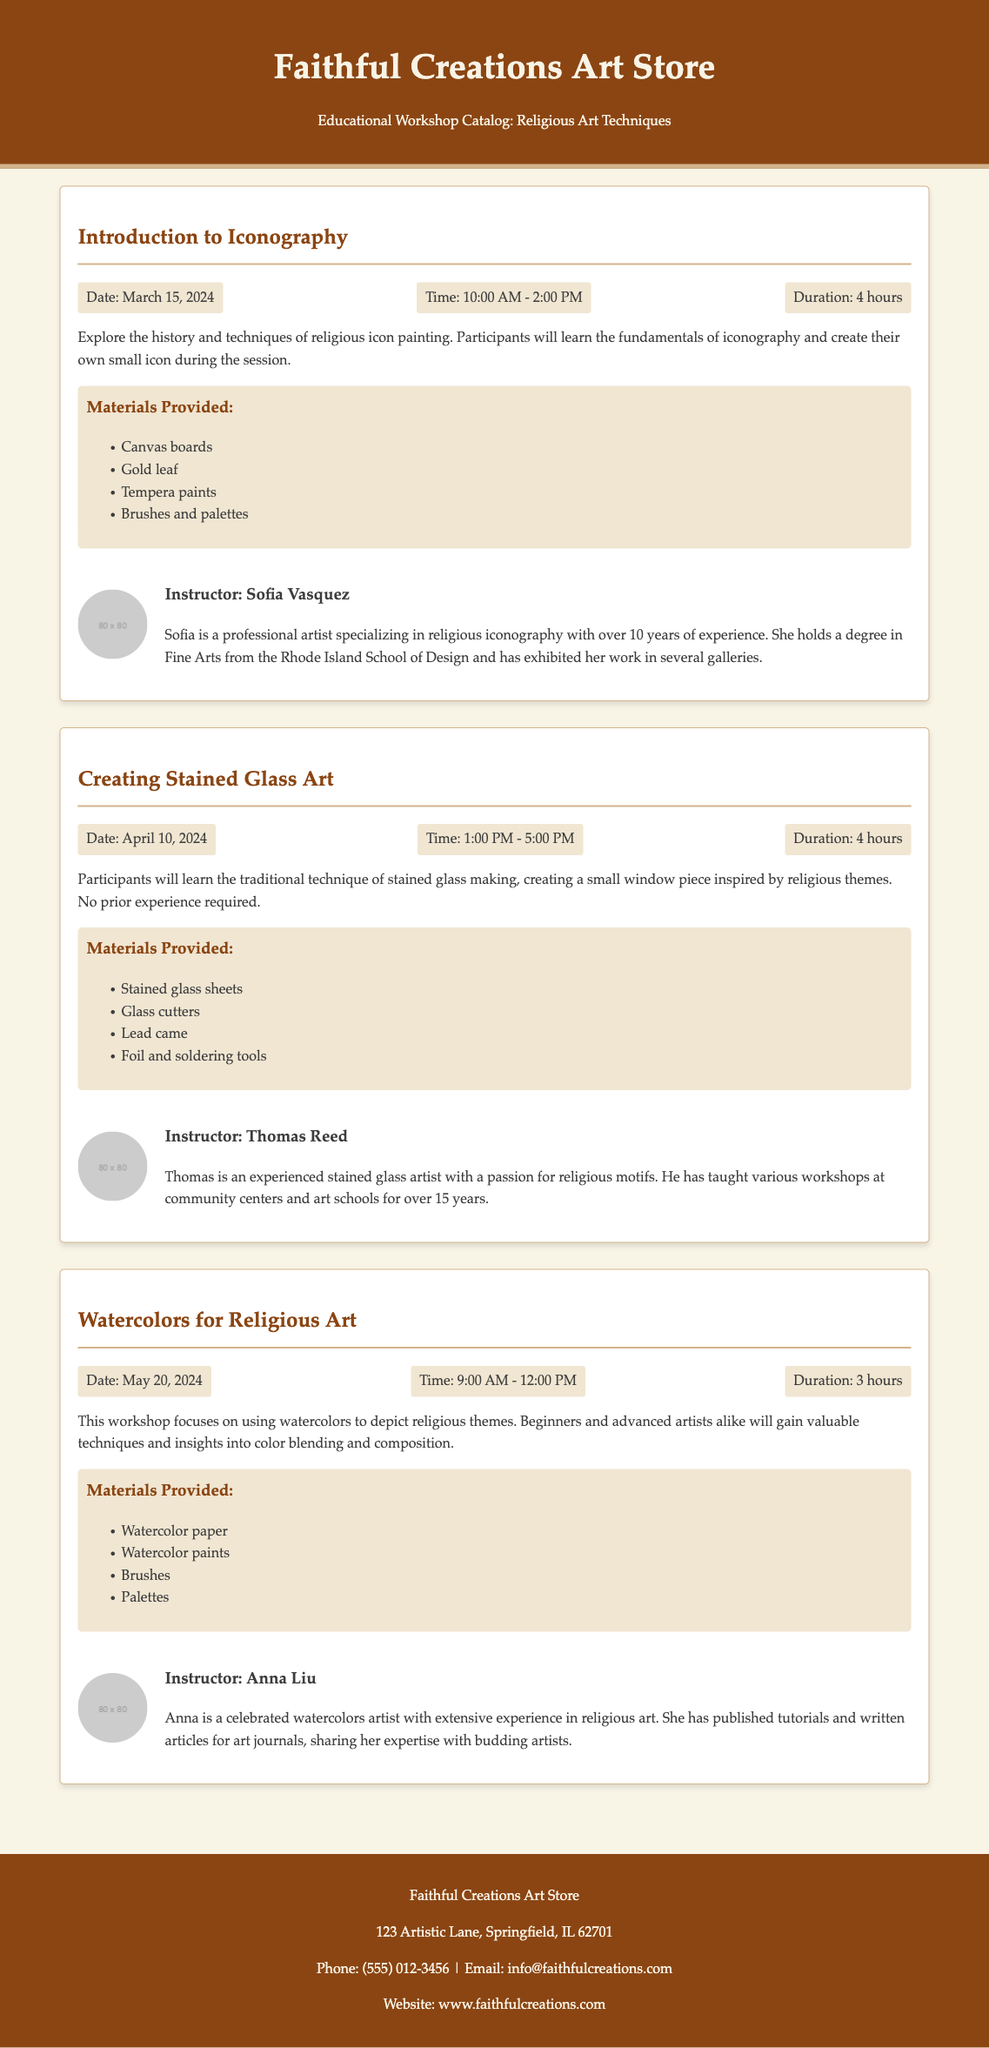What is the title of the first workshop? The title of the first workshop is found in the header of the workshop section labeled "Introduction to Iconography."
Answer: Introduction to Iconography When is the stained glass workshop scheduled? The date for the stained glass workshop is specified under the "Creating Stained Glass Art" title as April 10, 2024.
Answer: April 10, 2024 Who is the instructor of the watercolors workshop? The document lists the instructor for the watercolors workshop as Anna Liu under the "Watercolors for Religious Art" section.
Answer: Anna Liu How long is the Introduction to Iconography workshop? The duration of the workshop is stated in the details section for the "Introduction to Iconography," which is 4 hours.
Answer: 4 hours What materials are provided for the stained glass workshop? The document lists materials for the stained glass workshop under the "Materials Provided" section, including stained glass sheets, glass cutters, lead came, and foil and soldering tools.
Answer: Stained glass sheets, glass cutters, lead came, foil and soldering tools Which workshop has the shortest duration? To find the workshop with the shortest duration, we compare the durations given; the "Watercolors for Religious Art" workshop has a duration of 3 hours, which is the least.
Answer: 3 hours What is the email address listed for the art store? The email address for contacting the art store is given in the footer section of the document.
Answer: info@faithfulcreations.com What type of arts will be explored during the workshops? The workshops focus on various techniques of religious art, as mentioned in the introduction and details of each workshop.
Answer: Religious art How many hours long is the workshop on creating stained glass art? The duration of the "Creating Stained Glass Art" workshop is specified in its details as 4 hours.
Answer: 4 hours 